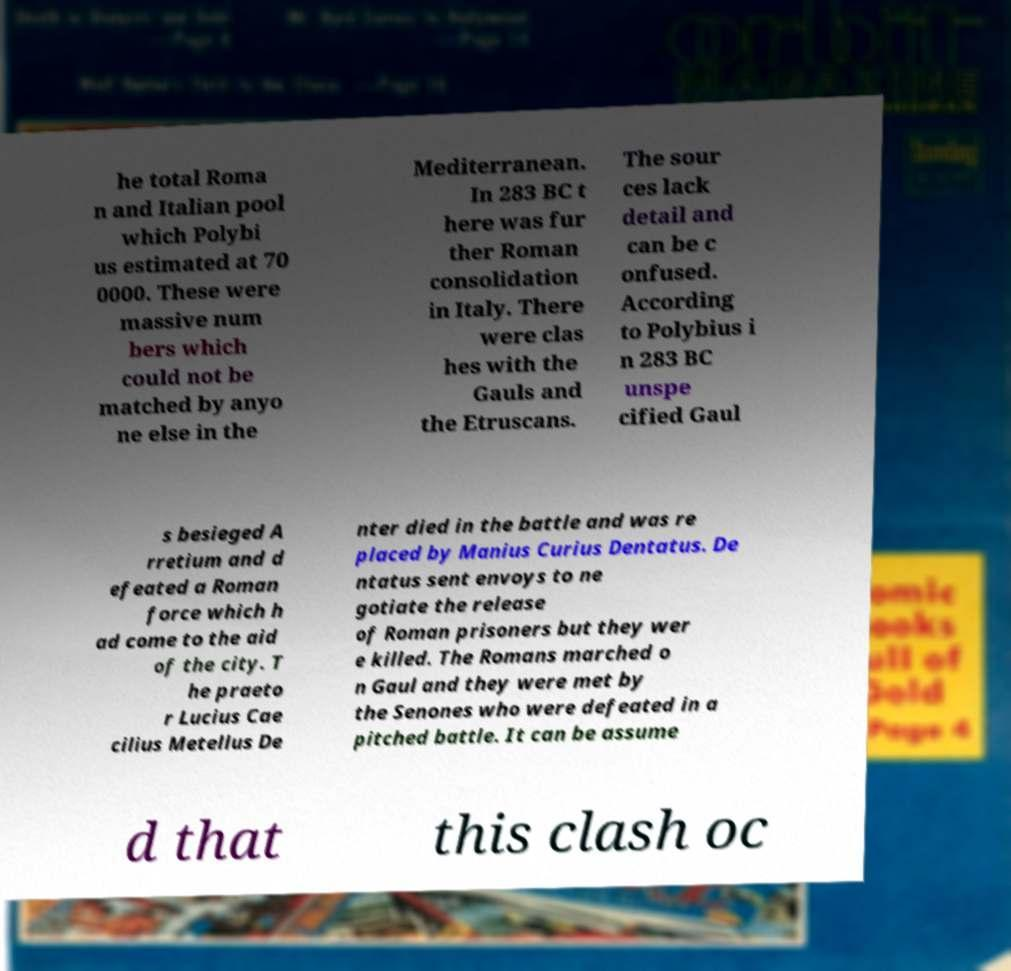Please read and relay the text visible in this image. What does it say? he total Roma n and Italian pool which Polybi us estimated at 70 0000. These were massive num bers which could not be matched by anyo ne else in the Mediterranean. In 283 BC t here was fur ther Roman consolidation in Italy. There were clas hes with the Gauls and the Etruscans. The sour ces lack detail and can be c onfused. According to Polybius i n 283 BC unspe cified Gaul s besieged A rretium and d efeated a Roman force which h ad come to the aid of the city. T he praeto r Lucius Cae cilius Metellus De nter died in the battle and was re placed by Manius Curius Dentatus. De ntatus sent envoys to ne gotiate the release of Roman prisoners but they wer e killed. The Romans marched o n Gaul and they were met by the Senones who were defeated in a pitched battle. It can be assume d that this clash oc 